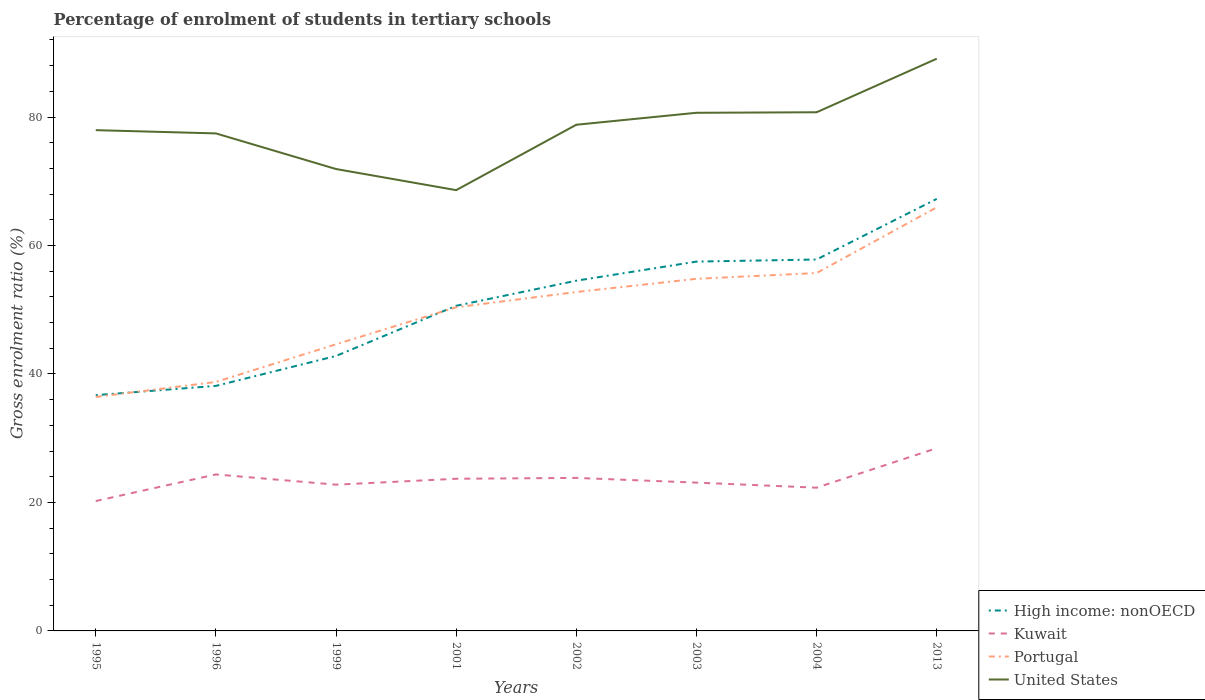How many different coloured lines are there?
Give a very brief answer. 4. Does the line corresponding to High income: nonOECD intersect with the line corresponding to United States?
Make the answer very short. No. Across all years, what is the maximum percentage of students enrolled in tertiary schools in United States?
Provide a succinct answer. 68.62. What is the total percentage of students enrolled in tertiary schools in United States in the graph?
Your answer should be very brief. -8.84. What is the difference between the highest and the second highest percentage of students enrolled in tertiary schools in Portugal?
Keep it short and to the point. 29.52. Is the percentage of students enrolled in tertiary schools in Portugal strictly greater than the percentage of students enrolled in tertiary schools in Kuwait over the years?
Offer a very short reply. No. How many years are there in the graph?
Offer a terse response. 8. Are the values on the major ticks of Y-axis written in scientific E-notation?
Provide a succinct answer. No. Does the graph contain any zero values?
Keep it short and to the point. No. Does the graph contain grids?
Provide a short and direct response. No. How many legend labels are there?
Keep it short and to the point. 4. How are the legend labels stacked?
Make the answer very short. Vertical. What is the title of the graph?
Offer a terse response. Percentage of enrolment of students in tertiary schools. Does "Ethiopia" appear as one of the legend labels in the graph?
Your answer should be very brief. No. What is the label or title of the X-axis?
Provide a succinct answer. Years. What is the Gross enrolment ratio (%) of High income: nonOECD in 1995?
Ensure brevity in your answer.  36.7. What is the Gross enrolment ratio (%) of Kuwait in 1995?
Your response must be concise. 20.22. What is the Gross enrolment ratio (%) in Portugal in 1995?
Provide a succinct answer. 36.43. What is the Gross enrolment ratio (%) in United States in 1995?
Your answer should be very brief. 77.96. What is the Gross enrolment ratio (%) in High income: nonOECD in 1996?
Keep it short and to the point. 38.15. What is the Gross enrolment ratio (%) of Kuwait in 1996?
Give a very brief answer. 24.36. What is the Gross enrolment ratio (%) of Portugal in 1996?
Your answer should be very brief. 38.76. What is the Gross enrolment ratio (%) in United States in 1996?
Ensure brevity in your answer.  77.45. What is the Gross enrolment ratio (%) in High income: nonOECD in 1999?
Your answer should be very brief. 42.8. What is the Gross enrolment ratio (%) in Kuwait in 1999?
Provide a succinct answer. 22.77. What is the Gross enrolment ratio (%) of Portugal in 1999?
Offer a very short reply. 44.62. What is the Gross enrolment ratio (%) in United States in 1999?
Your answer should be compact. 71.91. What is the Gross enrolment ratio (%) in High income: nonOECD in 2001?
Provide a succinct answer. 50.62. What is the Gross enrolment ratio (%) in Kuwait in 2001?
Offer a terse response. 23.69. What is the Gross enrolment ratio (%) in Portugal in 2001?
Your answer should be very brief. 50.38. What is the Gross enrolment ratio (%) in United States in 2001?
Offer a terse response. 68.62. What is the Gross enrolment ratio (%) of High income: nonOECD in 2002?
Offer a very short reply. 54.52. What is the Gross enrolment ratio (%) in Kuwait in 2002?
Your answer should be very brief. 23.82. What is the Gross enrolment ratio (%) of Portugal in 2002?
Provide a short and direct response. 52.76. What is the Gross enrolment ratio (%) of United States in 2002?
Keep it short and to the point. 78.8. What is the Gross enrolment ratio (%) in High income: nonOECD in 2003?
Provide a succinct answer. 57.49. What is the Gross enrolment ratio (%) in Kuwait in 2003?
Offer a terse response. 23.09. What is the Gross enrolment ratio (%) in Portugal in 2003?
Your answer should be very brief. 54.82. What is the Gross enrolment ratio (%) of United States in 2003?
Make the answer very short. 80.66. What is the Gross enrolment ratio (%) in High income: nonOECD in 2004?
Offer a very short reply. 57.82. What is the Gross enrolment ratio (%) of Kuwait in 2004?
Provide a short and direct response. 22.3. What is the Gross enrolment ratio (%) of Portugal in 2004?
Your answer should be compact. 55.71. What is the Gross enrolment ratio (%) in United States in 2004?
Give a very brief answer. 80.74. What is the Gross enrolment ratio (%) in High income: nonOECD in 2013?
Make the answer very short. 67.26. What is the Gross enrolment ratio (%) of Kuwait in 2013?
Make the answer very short. 28.45. What is the Gross enrolment ratio (%) in Portugal in 2013?
Your answer should be very brief. 65.95. What is the Gross enrolment ratio (%) of United States in 2013?
Your answer should be compact. 89.08. Across all years, what is the maximum Gross enrolment ratio (%) in High income: nonOECD?
Your answer should be very brief. 67.26. Across all years, what is the maximum Gross enrolment ratio (%) of Kuwait?
Your answer should be compact. 28.45. Across all years, what is the maximum Gross enrolment ratio (%) in Portugal?
Your response must be concise. 65.95. Across all years, what is the maximum Gross enrolment ratio (%) of United States?
Provide a short and direct response. 89.08. Across all years, what is the minimum Gross enrolment ratio (%) of High income: nonOECD?
Your response must be concise. 36.7. Across all years, what is the minimum Gross enrolment ratio (%) in Kuwait?
Provide a short and direct response. 20.22. Across all years, what is the minimum Gross enrolment ratio (%) in Portugal?
Offer a terse response. 36.43. Across all years, what is the minimum Gross enrolment ratio (%) in United States?
Ensure brevity in your answer.  68.62. What is the total Gross enrolment ratio (%) of High income: nonOECD in the graph?
Provide a succinct answer. 405.37. What is the total Gross enrolment ratio (%) in Kuwait in the graph?
Your answer should be very brief. 188.7. What is the total Gross enrolment ratio (%) of Portugal in the graph?
Offer a very short reply. 399.43. What is the total Gross enrolment ratio (%) of United States in the graph?
Offer a terse response. 625.22. What is the difference between the Gross enrolment ratio (%) of High income: nonOECD in 1995 and that in 1996?
Keep it short and to the point. -1.44. What is the difference between the Gross enrolment ratio (%) in Kuwait in 1995 and that in 1996?
Keep it short and to the point. -4.14. What is the difference between the Gross enrolment ratio (%) in Portugal in 1995 and that in 1996?
Offer a terse response. -2.33. What is the difference between the Gross enrolment ratio (%) of United States in 1995 and that in 1996?
Your answer should be very brief. 0.51. What is the difference between the Gross enrolment ratio (%) of High income: nonOECD in 1995 and that in 1999?
Keep it short and to the point. -6.1. What is the difference between the Gross enrolment ratio (%) in Kuwait in 1995 and that in 1999?
Ensure brevity in your answer.  -2.55. What is the difference between the Gross enrolment ratio (%) in Portugal in 1995 and that in 1999?
Provide a succinct answer. -8.2. What is the difference between the Gross enrolment ratio (%) of United States in 1995 and that in 1999?
Ensure brevity in your answer.  6.05. What is the difference between the Gross enrolment ratio (%) of High income: nonOECD in 1995 and that in 2001?
Give a very brief answer. -13.91. What is the difference between the Gross enrolment ratio (%) of Kuwait in 1995 and that in 2001?
Give a very brief answer. -3.47. What is the difference between the Gross enrolment ratio (%) of Portugal in 1995 and that in 2001?
Your answer should be compact. -13.95. What is the difference between the Gross enrolment ratio (%) in United States in 1995 and that in 2001?
Ensure brevity in your answer.  9.34. What is the difference between the Gross enrolment ratio (%) of High income: nonOECD in 1995 and that in 2002?
Your answer should be compact. -17.82. What is the difference between the Gross enrolment ratio (%) of Kuwait in 1995 and that in 2002?
Provide a short and direct response. -3.6. What is the difference between the Gross enrolment ratio (%) in Portugal in 1995 and that in 2002?
Offer a terse response. -16.33. What is the difference between the Gross enrolment ratio (%) in United States in 1995 and that in 2002?
Provide a succinct answer. -0.84. What is the difference between the Gross enrolment ratio (%) of High income: nonOECD in 1995 and that in 2003?
Ensure brevity in your answer.  -20.79. What is the difference between the Gross enrolment ratio (%) of Kuwait in 1995 and that in 2003?
Ensure brevity in your answer.  -2.87. What is the difference between the Gross enrolment ratio (%) in Portugal in 1995 and that in 2003?
Provide a succinct answer. -18.39. What is the difference between the Gross enrolment ratio (%) in United States in 1995 and that in 2003?
Your answer should be very brief. -2.71. What is the difference between the Gross enrolment ratio (%) in High income: nonOECD in 1995 and that in 2004?
Keep it short and to the point. -21.12. What is the difference between the Gross enrolment ratio (%) of Kuwait in 1995 and that in 2004?
Your answer should be very brief. -2.08. What is the difference between the Gross enrolment ratio (%) of Portugal in 1995 and that in 2004?
Make the answer very short. -19.29. What is the difference between the Gross enrolment ratio (%) of United States in 1995 and that in 2004?
Offer a very short reply. -2.79. What is the difference between the Gross enrolment ratio (%) of High income: nonOECD in 1995 and that in 2013?
Make the answer very short. -30.55. What is the difference between the Gross enrolment ratio (%) in Kuwait in 1995 and that in 2013?
Keep it short and to the point. -8.23. What is the difference between the Gross enrolment ratio (%) of Portugal in 1995 and that in 2013?
Your answer should be compact. -29.52. What is the difference between the Gross enrolment ratio (%) of United States in 1995 and that in 2013?
Your answer should be compact. -11.13. What is the difference between the Gross enrolment ratio (%) in High income: nonOECD in 1996 and that in 1999?
Your answer should be very brief. -4.66. What is the difference between the Gross enrolment ratio (%) of Kuwait in 1996 and that in 1999?
Offer a very short reply. 1.6. What is the difference between the Gross enrolment ratio (%) in Portugal in 1996 and that in 1999?
Your response must be concise. -5.86. What is the difference between the Gross enrolment ratio (%) in United States in 1996 and that in 1999?
Your answer should be very brief. 5.55. What is the difference between the Gross enrolment ratio (%) in High income: nonOECD in 1996 and that in 2001?
Offer a very short reply. -12.47. What is the difference between the Gross enrolment ratio (%) of Kuwait in 1996 and that in 2001?
Provide a short and direct response. 0.68. What is the difference between the Gross enrolment ratio (%) of Portugal in 1996 and that in 2001?
Make the answer very short. -11.62. What is the difference between the Gross enrolment ratio (%) of United States in 1996 and that in 2001?
Give a very brief answer. 8.83. What is the difference between the Gross enrolment ratio (%) in High income: nonOECD in 1996 and that in 2002?
Provide a short and direct response. -16.38. What is the difference between the Gross enrolment ratio (%) of Kuwait in 1996 and that in 2002?
Offer a very short reply. 0.54. What is the difference between the Gross enrolment ratio (%) of Portugal in 1996 and that in 2002?
Provide a succinct answer. -14. What is the difference between the Gross enrolment ratio (%) of United States in 1996 and that in 2002?
Keep it short and to the point. -1.35. What is the difference between the Gross enrolment ratio (%) of High income: nonOECD in 1996 and that in 2003?
Offer a terse response. -19.35. What is the difference between the Gross enrolment ratio (%) in Kuwait in 1996 and that in 2003?
Ensure brevity in your answer.  1.27. What is the difference between the Gross enrolment ratio (%) of Portugal in 1996 and that in 2003?
Your answer should be compact. -16.06. What is the difference between the Gross enrolment ratio (%) in United States in 1996 and that in 2003?
Your response must be concise. -3.21. What is the difference between the Gross enrolment ratio (%) in High income: nonOECD in 1996 and that in 2004?
Make the answer very short. -19.68. What is the difference between the Gross enrolment ratio (%) of Kuwait in 1996 and that in 2004?
Offer a terse response. 2.06. What is the difference between the Gross enrolment ratio (%) of Portugal in 1996 and that in 2004?
Offer a very short reply. -16.95. What is the difference between the Gross enrolment ratio (%) of United States in 1996 and that in 2004?
Ensure brevity in your answer.  -3.29. What is the difference between the Gross enrolment ratio (%) in High income: nonOECD in 1996 and that in 2013?
Provide a short and direct response. -29.11. What is the difference between the Gross enrolment ratio (%) of Kuwait in 1996 and that in 2013?
Your answer should be compact. -4.09. What is the difference between the Gross enrolment ratio (%) of Portugal in 1996 and that in 2013?
Your answer should be compact. -27.18. What is the difference between the Gross enrolment ratio (%) in United States in 1996 and that in 2013?
Provide a short and direct response. -11.63. What is the difference between the Gross enrolment ratio (%) of High income: nonOECD in 1999 and that in 2001?
Your answer should be very brief. -7.81. What is the difference between the Gross enrolment ratio (%) in Kuwait in 1999 and that in 2001?
Your response must be concise. -0.92. What is the difference between the Gross enrolment ratio (%) in Portugal in 1999 and that in 2001?
Offer a terse response. -5.76. What is the difference between the Gross enrolment ratio (%) in United States in 1999 and that in 2001?
Your response must be concise. 3.29. What is the difference between the Gross enrolment ratio (%) in High income: nonOECD in 1999 and that in 2002?
Keep it short and to the point. -11.72. What is the difference between the Gross enrolment ratio (%) in Kuwait in 1999 and that in 2002?
Offer a terse response. -1.05. What is the difference between the Gross enrolment ratio (%) in Portugal in 1999 and that in 2002?
Make the answer very short. -8.14. What is the difference between the Gross enrolment ratio (%) of United States in 1999 and that in 2002?
Provide a short and direct response. -6.89. What is the difference between the Gross enrolment ratio (%) in High income: nonOECD in 1999 and that in 2003?
Ensure brevity in your answer.  -14.69. What is the difference between the Gross enrolment ratio (%) of Kuwait in 1999 and that in 2003?
Give a very brief answer. -0.32. What is the difference between the Gross enrolment ratio (%) in Portugal in 1999 and that in 2003?
Your answer should be compact. -10.19. What is the difference between the Gross enrolment ratio (%) of United States in 1999 and that in 2003?
Offer a terse response. -8.76. What is the difference between the Gross enrolment ratio (%) of High income: nonOECD in 1999 and that in 2004?
Offer a terse response. -15.02. What is the difference between the Gross enrolment ratio (%) of Kuwait in 1999 and that in 2004?
Your answer should be compact. 0.47. What is the difference between the Gross enrolment ratio (%) in Portugal in 1999 and that in 2004?
Offer a terse response. -11.09. What is the difference between the Gross enrolment ratio (%) of United States in 1999 and that in 2004?
Ensure brevity in your answer.  -8.84. What is the difference between the Gross enrolment ratio (%) in High income: nonOECD in 1999 and that in 2013?
Your answer should be very brief. -24.45. What is the difference between the Gross enrolment ratio (%) in Kuwait in 1999 and that in 2013?
Give a very brief answer. -5.68. What is the difference between the Gross enrolment ratio (%) of Portugal in 1999 and that in 2013?
Your response must be concise. -21.32. What is the difference between the Gross enrolment ratio (%) of United States in 1999 and that in 2013?
Give a very brief answer. -17.18. What is the difference between the Gross enrolment ratio (%) in High income: nonOECD in 2001 and that in 2002?
Your response must be concise. -3.91. What is the difference between the Gross enrolment ratio (%) in Kuwait in 2001 and that in 2002?
Provide a short and direct response. -0.13. What is the difference between the Gross enrolment ratio (%) in Portugal in 2001 and that in 2002?
Your response must be concise. -2.38. What is the difference between the Gross enrolment ratio (%) of United States in 2001 and that in 2002?
Provide a short and direct response. -10.18. What is the difference between the Gross enrolment ratio (%) of High income: nonOECD in 2001 and that in 2003?
Your response must be concise. -6.88. What is the difference between the Gross enrolment ratio (%) of Kuwait in 2001 and that in 2003?
Provide a short and direct response. 0.6. What is the difference between the Gross enrolment ratio (%) of Portugal in 2001 and that in 2003?
Your answer should be very brief. -4.44. What is the difference between the Gross enrolment ratio (%) in United States in 2001 and that in 2003?
Your answer should be compact. -12.04. What is the difference between the Gross enrolment ratio (%) of High income: nonOECD in 2001 and that in 2004?
Offer a very short reply. -7.21. What is the difference between the Gross enrolment ratio (%) in Kuwait in 2001 and that in 2004?
Make the answer very short. 1.39. What is the difference between the Gross enrolment ratio (%) of Portugal in 2001 and that in 2004?
Your answer should be very brief. -5.33. What is the difference between the Gross enrolment ratio (%) in United States in 2001 and that in 2004?
Provide a short and direct response. -12.12. What is the difference between the Gross enrolment ratio (%) in High income: nonOECD in 2001 and that in 2013?
Provide a short and direct response. -16.64. What is the difference between the Gross enrolment ratio (%) of Kuwait in 2001 and that in 2013?
Your response must be concise. -4.76. What is the difference between the Gross enrolment ratio (%) in Portugal in 2001 and that in 2013?
Offer a very short reply. -15.57. What is the difference between the Gross enrolment ratio (%) in United States in 2001 and that in 2013?
Give a very brief answer. -20.46. What is the difference between the Gross enrolment ratio (%) of High income: nonOECD in 2002 and that in 2003?
Offer a terse response. -2.97. What is the difference between the Gross enrolment ratio (%) of Kuwait in 2002 and that in 2003?
Ensure brevity in your answer.  0.73. What is the difference between the Gross enrolment ratio (%) in Portugal in 2002 and that in 2003?
Offer a very short reply. -2.06. What is the difference between the Gross enrolment ratio (%) of United States in 2002 and that in 2003?
Provide a succinct answer. -1.86. What is the difference between the Gross enrolment ratio (%) in High income: nonOECD in 2002 and that in 2004?
Keep it short and to the point. -3.3. What is the difference between the Gross enrolment ratio (%) of Kuwait in 2002 and that in 2004?
Your response must be concise. 1.52. What is the difference between the Gross enrolment ratio (%) of Portugal in 2002 and that in 2004?
Give a very brief answer. -2.95. What is the difference between the Gross enrolment ratio (%) of United States in 2002 and that in 2004?
Ensure brevity in your answer.  -1.94. What is the difference between the Gross enrolment ratio (%) in High income: nonOECD in 2002 and that in 2013?
Your response must be concise. -12.74. What is the difference between the Gross enrolment ratio (%) of Kuwait in 2002 and that in 2013?
Make the answer very short. -4.63. What is the difference between the Gross enrolment ratio (%) of Portugal in 2002 and that in 2013?
Your answer should be very brief. -13.18. What is the difference between the Gross enrolment ratio (%) in United States in 2002 and that in 2013?
Ensure brevity in your answer.  -10.28. What is the difference between the Gross enrolment ratio (%) in High income: nonOECD in 2003 and that in 2004?
Provide a succinct answer. -0.33. What is the difference between the Gross enrolment ratio (%) in Kuwait in 2003 and that in 2004?
Offer a very short reply. 0.79. What is the difference between the Gross enrolment ratio (%) of Portugal in 2003 and that in 2004?
Offer a terse response. -0.89. What is the difference between the Gross enrolment ratio (%) of United States in 2003 and that in 2004?
Provide a short and direct response. -0.08. What is the difference between the Gross enrolment ratio (%) in High income: nonOECD in 2003 and that in 2013?
Provide a short and direct response. -9.76. What is the difference between the Gross enrolment ratio (%) in Kuwait in 2003 and that in 2013?
Give a very brief answer. -5.36. What is the difference between the Gross enrolment ratio (%) of Portugal in 2003 and that in 2013?
Make the answer very short. -11.13. What is the difference between the Gross enrolment ratio (%) in United States in 2003 and that in 2013?
Give a very brief answer. -8.42. What is the difference between the Gross enrolment ratio (%) of High income: nonOECD in 2004 and that in 2013?
Give a very brief answer. -9.44. What is the difference between the Gross enrolment ratio (%) in Kuwait in 2004 and that in 2013?
Ensure brevity in your answer.  -6.15. What is the difference between the Gross enrolment ratio (%) of Portugal in 2004 and that in 2013?
Your answer should be very brief. -10.23. What is the difference between the Gross enrolment ratio (%) in United States in 2004 and that in 2013?
Provide a succinct answer. -8.34. What is the difference between the Gross enrolment ratio (%) of High income: nonOECD in 1995 and the Gross enrolment ratio (%) of Kuwait in 1996?
Ensure brevity in your answer.  12.34. What is the difference between the Gross enrolment ratio (%) in High income: nonOECD in 1995 and the Gross enrolment ratio (%) in Portugal in 1996?
Provide a succinct answer. -2.06. What is the difference between the Gross enrolment ratio (%) in High income: nonOECD in 1995 and the Gross enrolment ratio (%) in United States in 1996?
Provide a succinct answer. -40.75. What is the difference between the Gross enrolment ratio (%) of Kuwait in 1995 and the Gross enrolment ratio (%) of Portugal in 1996?
Provide a short and direct response. -18.54. What is the difference between the Gross enrolment ratio (%) in Kuwait in 1995 and the Gross enrolment ratio (%) in United States in 1996?
Give a very brief answer. -57.23. What is the difference between the Gross enrolment ratio (%) of Portugal in 1995 and the Gross enrolment ratio (%) of United States in 1996?
Give a very brief answer. -41.02. What is the difference between the Gross enrolment ratio (%) in High income: nonOECD in 1995 and the Gross enrolment ratio (%) in Kuwait in 1999?
Offer a terse response. 13.94. What is the difference between the Gross enrolment ratio (%) of High income: nonOECD in 1995 and the Gross enrolment ratio (%) of Portugal in 1999?
Make the answer very short. -7.92. What is the difference between the Gross enrolment ratio (%) of High income: nonOECD in 1995 and the Gross enrolment ratio (%) of United States in 1999?
Make the answer very short. -35.2. What is the difference between the Gross enrolment ratio (%) of Kuwait in 1995 and the Gross enrolment ratio (%) of Portugal in 1999?
Make the answer very short. -24.4. What is the difference between the Gross enrolment ratio (%) in Kuwait in 1995 and the Gross enrolment ratio (%) in United States in 1999?
Offer a very short reply. -51.68. What is the difference between the Gross enrolment ratio (%) of Portugal in 1995 and the Gross enrolment ratio (%) of United States in 1999?
Ensure brevity in your answer.  -35.48. What is the difference between the Gross enrolment ratio (%) in High income: nonOECD in 1995 and the Gross enrolment ratio (%) in Kuwait in 2001?
Provide a short and direct response. 13.02. What is the difference between the Gross enrolment ratio (%) of High income: nonOECD in 1995 and the Gross enrolment ratio (%) of Portugal in 2001?
Provide a short and direct response. -13.68. What is the difference between the Gross enrolment ratio (%) in High income: nonOECD in 1995 and the Gross enrolment ratio (%) in United States in 2001?
Your answer should be very brief. -31.91. What is the difference between the Gross enrolment ratio (%) in Kuwait in 1995 and the Gross enrolment ratio (%) in Portugal in 2001?
Offer a terse response. -30.16. What is the difference between the Gross enrolment ratio (%) of Kuwait in 1995 and the Gross enrolment ratio (%) of United States in 2001?
Ensure brevity in your answer.  -48.4. What is the difference between the Gross enrolment ratio (%) of Portugal in 1995 and the Gross enrolment ratio (%) of United States in 2001?
Ensure brevity in your answer.  -32.19. What is the difference between the Gross enrolment ratio (%) in High income: nonOECD in 1995 and the Gross enrolment ratio (%) in Kuwait in 2002?
Ensure brevity in your answer.  12.88. What is the difference between the Gross enrolment ratio (%) in High income: nonOECD in 1995 and the Gross enrolment ratio (%) in Portugal in 2002?
Ensure brevity in your answer.  -16.06. What is the difference between the Gross enrolment ratio (%) in High income: nonOECD in 1995 and the Gross enrolment ratio (%) in United States in 2002?
Your answer should be compact. -42.1. What is the difference between the Gross enrolment ratio (%) of Kuwait in 1995 and the Gross enrolment ratio (%) of Portugal in 2002?
Keep it short and to the point. -32.54. What is the difference between the Gross enrolment ratio (%) of Kuwait in 1995 and the Gross enrolment ratio (%) of United States in 2002?
Make the answer very short. -58.58. What is the difference between the Gross enrolment ratio (%) in Portugal in 1995 and the Gross enrolment ratio (%) in United States in 2002?
Keep it short and to the point. -42.37. What is the difference between the Gross enrolment ratio (%) in High income: nonOECD in 1995 and the Gross enrolment ratio (%) in Kuwait in 2003?
Your answer should be compact. 13.62. What is the difference between the Gross enrolment ratio (%) in High income: nonOECD in 1995 and the Gross enrolment ratio (%) in Portugal in 2003?
Keep it short and to the point. -18.11. What is the difference between the Gross enrolment ratio (%) of High income: nonOECD in 1995 and the Gross enrolment ratio (%) of United States in 2003?
Provide a succinct answer. -43.96. What is the difference between the Gross enrolment ratio (%) in Kuwait in 1995 and the Gross enrolment ratio (%) in Portugal in 2003?
Give a very brief answer. -34.6. What is the difference between the Gross enrolment ratio (%) in Kuwait in 1995 and the Gross enrolment ratio (%) in United States in 2003?
Make the answer very short. -60.44. What is the difference between the Gross enrolment ratio (%) of Portugal in 1995 and the Gross enrolment ratio (%) of United States in 2003?
Ensure brevity in your answer.  -44.24. What is the difference between the Gross enrolment ratio (%) of High income: nonOECD in 1995 and the Gross enrolment ratio (%) of Kuwait in 2004?
Provide a succinct answer. 14.4. What is the difference between the Gross enrolment ratio (%) in High income: nonOECD in 1995 and the Gross enrolment ratio (%) in Portugal in 2004?
Your response must be concise. -19.01. What is the difference between the Gross enrolment ratio (%) in High income: nonOECD in 1995 and the Gross enrolment ratio (%) in United States in 2004?
Provide a succinct answer. -44.04. What is the difference between the Gross enrolment ratio (%) of Kuwait in 1995 and the Gross enrolment ratio (%) of Portugal in 2004?
Provide a short and direct response. -35.49. What is the difference between the Gross enrolment ratio (%) of Kuwait in 1995 and the Gross enrolment ratio (%) of United States in 2004?
Make the answer very short. -60.52. What is the difference between the Gross enrolment ratio (%) in Portugal in 1995 and the Gross enrolment ratio (%) in United States in 2004?
Make the answer very short. -44.32. What is the difference between the Gross enrolment ratio (%) of High income: nonOECD in 1995 and the Gross enrolment ratio (%) of Kuwait in 2013?
Your response must be concise. 8.25. What is the difference between the Gross enrolment ratio (%) of High income: nonOECD in 1995 and the Gross enrolment ratio (%) of Portugal in 2013?
Offer a terse response. -29.24. What is the difference between the Gross enrolment ratio (%) of High income: nonOECD in 1995 and the Gross enrolment ratio (%) of United States in 2013?
Provide a succinct answer. -52.38. What is the difference between the Gross enrolment ratio (%) of Kuwait in 1995 and the Gross enrolment ratio (%) of Portugal in 2013?
Your answer should be very brief. -45.72. What is the difference between the Gross enrolment ratio (%) in Kuwait in 1995 and the Gross enrolment ratio (%) in United States in 2013?
Provide a short and direct response. -68.86. What is the difference between the Gross enrolment ratio (%) of Portugal in 1995 and the Gross enrolment ratio (%) of United States in 2013?
Your response must be concise. -52.66. What is the difference between the Gross enrolment ratio (%) of High income: nonOECD in 1996 and the Gross enrolment ratio (%) of Kuwait in 1999?
Ensure brevity in your answer.  15.38. What is the difference between the Gross enrolment ratio (%) in High income: nonOECD in 1996 and the Gross enrolment ratio (%) in Portugal in 1999?
Your answer should be compact. -6.48. What is the difference between the Gross enrolment ratio (%) of High income: nonOECD in 1996 and the Gross enrolment ratio (%) of United States in 1999?
Ensure brevity in your answer.  -33.76. What is the difference between the Gross enrolment ratio (%) of Kuwait in 1996 and the Gross enrolment ratio (%) of Portugal in 1999?
Ensure brevity in your answer.  -20.26. What is the difference between the Gross enrolment ratio (%) of Kuwait in 1996 and the Gross enrolment ratio (%) of United States in 1999?
Make the answer very short. -47.54. What is the difference between the Gross enrolment ratio (%) in Portugal in 1996 and the Gross enrolment ratio (%) in United States in 1999?
Provide a short and direct response. -33.14. What is the difference between the Gross enrolment ratio (%) of High income: nonOECD in 1996 and the Gross enrolment ratio (%) of Kuwait in 2001?
Ensure brevity in your answer.  14.46. What is the difference between the Gross enrolment ratio (%) of High income: nonOECD in 1996 and the Gross enrolment ratio (%) of Portugal in 2001?
Offer a terse response. -12.23. What is the difference between the Gross enrolment ratio (%) of High income: nonOECD in 1996 and the Gross enrolment ratio (%) of United States in 2001?
Provide a succinct answer. -30.47. What is the difference between the Gross enrolment ratio (%) in Kuwait in 1996 and the Gross enrolment ratio (%) in Portugal in 2001?
Provide a succinct answer. -26.02. What is the difference between the Gross enrolment ratio (%) in Kuwait in 1996 and the Gross enrolment ratio (%) in United States in 2001?
Give a very brief answer. -44.25. What is the difference between the Gross enrolment ratio (%) in Portugal in 1996 and the Gross enrolment ratio (%) in United States in 2001?
Give a very brief answer. -29.86. What is the difference between the Gross enrolment ratio (%) of High income: nonOECD in 1996 and the Gross enrolment ratio (%) of Kuwait in 2002?
Keep it short and to the point. 14.33. What is the difference between the Gross enrolment ratio (%) of High income: nonOECD in 1996 and the Gross enrolment ratio (%) of Portugal in 2002?
Your answer should be very brief. -14.61. What is the difference between the Gross enrolment ratio (%) in High income: nonOECD in 1996 and the Gross enrolment ratio (%) in United States in 2002?
Give a very brief answer. -40.65. What is the difference between the Gross enrolment ratio (%) in Kuwait in 1996 and the Gross enrolment ratio (%) in Portugal in 2002?
Make the answer very short. -28.4. What is the difference between the Gross enrolment ratio (%) of Kuwait in 1996 and the Gross enrolment ratio (%) of United States in 2002?
Ensure brevity in your answer.  -54.44. What is the difference between the Gross enrolment ratio (%) in Portugal in 1996 and the Gross enrolment ratio (%) in United States in 2002?
Provide a short and direct response. -40.04. What is the difference between the Gross enrolment ratio (%) in High income: nonOECD in 1996 and the Gross enrolment ratio (%) in Kuwait in 2003?
Offer a very short reply. 15.06. What is the difference between the Gross enrolment ratio (%) in High income: nonOECD in 1996 and the Gross enrolment ratio (%) in Portugal in 2003?
Provide a short and direct response. -16.67. What is the difference between the Gross enrolment ratio (%) in High income: nonOECD in 1996 and the Gross enrolment ratio (%) in United States in 2003?
Offer a very short reply. -42.52. What is the difference between the Gross enrolment ratio (%) of Kuwait in 1996 and the Gross enrolment ratio (%) of Portugal in 2003?
Provide a short and direct response. -30.45. What is the difference between the Gross enrolment ratio (%) in Kuwait in 1996 and the Gross enrolment ratio (%) in United States in 2003?
Provide a short and direct response. -56.3. What is the difference between the Gross enrolment ratio (%) of Portugal in 1996 and the Gross enrolment ratio (%) of United States in 2003?
Your answer should be compact. -41.9. What is the difference between the Gross enrolment ratio (%) in High income: nonOECD in 1996 and the Gross enrolment ratio (%) in Kuwait in 2004?
Your answer should be compact. 15.85. What is the difference between the Gross enrolment ratio (%) of High income: nonOECD in 1996 and the Gross enrolment ratio (%) of Portugal in 2004?
Provide a short and direct response. -17.56. What is the difference between the Gross enrolment ratio (%) of High income: nonOECD in 1996 and the Gross enrolment ratio (%) of United States in 2004?
Provide a short and direct response. -42.6. What is the difference between the Gross enrolment ratio (%) of Kuwait in 1996 and the Gross enrolment ratio (%) of Portugal in 2004?
Provide a succinct answer. -31.35. What is the difference between the Gross enrolment ratio (%) of Kuwait in 1996 and the Gross enrolment ratio (%) of United States in 2004?
Your answer should be compact. -56.38. What is the difference between the Gross enrolment ratio (%) in Portugal in 1996 and the Gross enrolment ratio (%) in United States in 2004?
Provide a succinct answer. -41.98. What is the difference between the Gross enrolment ratio (%) of High income: nonOECD in 1996 and the Gross enrolment ratio (%) of Kuwait in 2013?
Ensure brevity in your answer.  9.7. What is the difference between the Gross enrolment ratio (%) in High income: nonOECD in 1996 and the Gross enrolment ratio (%) in Portugal in 2013?
Ensure brevity in your answer.  -27.8. What is the difference between the Gross enrolment ratio (%) in High income: nonOECD in 1996 and the Gross enrolment ratio (%) in United States in 2013?
Provide a short and direct response. -50.94. What is the difference between the Gross enrolment ratio (%) in Kuwait in 1996 and the Gross enrolment ratio (%) in Portugal in 2013?
Offer a very short reply. -41.58. What is the difference between the Gross enrolment ratio (%) of Kuwait in 1996 and the Gross enrolment ratio (%) of United States in 2013?
Make the answer very short. -64.72. What is the difference between the Gross enrolment ratio (%) of Portugal in 1996 and the Gross enrolment ratio (%) of United States in 2013?
Ensure brevity in your answer.  -50.32. What is the difference between the Gross enrolment ratio (%) of High income: nonOECD in 1999 and the Gross enrolment ratio (%) of Kuwait in 2001?
Provide a short and direct response. 19.12. What is the difference between the Gross enrolment ratio (%) in High income: nonOECD in 1999 and the Gross enrolment ratio (%) in Portugal in 2001?
Make the answer very short. -7.58. What is the difference between the Gross enrolment ratio (%) in High income: nonOECD in 1999 and the Gross enrolment ratio (%) in United States in 2001?
Your answer should be compact. -25.81. What is the difference between the Gross enrolment ratio (%) of Kuwait in 1999 and the Gross enrolment ratio (%) of Portugal in 2001?
Ensure brevity in your answer.  -27.61. What is the difference between the Gross enrolment ratio (%) in Kuwait in 1999 and the Gross enrolment ratio (%) in United States in 2001?
Offer a terse response. -45.85. What is the difference between the Gross enrolment ratio (%) in Portugal in 1999 and the Gross enrolment ratio (%) in United States in 2001?
Give a very brief answer. -23.99. What is the difference between the Gross enrolment ratio (%) in High income: nonOECD in 1999 and the Gross enrolment ratio (%) in Kuwait in 2002?
Your response must be concise. 18.98. What is the difference between the Gross enrolment ratio (%) of High income: nonOECD in 1999 and the Gross enrolment ratio (%) of Portugal in 2002?
Provide a short and direct response. -9.96. What is the difference between the Gross enrolment ratio (%) in High income: nonOECD in 1999 and the Gross enrolment ratio (%) in United States in 2002?
Keep it short and to the point. -36. What is the difference between the Gross enrolment ratio (%) of Kuwait in 1999 and the Gross enrolment ratio (%) of Portugal in 2002?
Provide a succinct answer. -29.99. What is the difference between the Gross enrolment ratio (%) in Kuwait in 1999 and the Gross enrolment ratio (%) in United States in 2002?
Offer a very short reply. -56.03. What is the difference between the Gross enrolment ratio (%) of Portugal in 1999 and the Gross enrolment ratio (%) of United States in 2002?
Provide a succinct answer. -34.18. What is the difference between the Gross enrolment ratio (%) in High income: nonOECD in 1999 and the Gross enrolment ratio (%) in Kuwait in 2003?
Provide a short and direct response. 19.72. What is the difference between the Gross enrolment ratio (%) of High income: nonOECD in 1999 and the Gross enrolment ratio (%) of Portugal in 2003?
Provide a succinct answer. -12.01. What is the difference between the Gross enrolment ratio (%) in High income: nonOECD in 1999 and the Gross enrolment ratio (%) in United States in 2003?
Offer a terse response. -37.86. What is the difference between the Gross enrolment ratio (%) of Kuwait in 1999 and the Gross enrolment ratio (%) of Portugal in 2003?
Keep it short and to the point. -32.05. What is the difference between the Gross enrolment ratio (%) in Kuwait in 1999 and the Gross enrolment ratio (%) in United States in 2003?
Ensure brevity in your answer.  -57.9. What is the difference between the Gross enrolment ratio (%) of Portugal in 1999 and the Gross enrolment ratio (%) of United States in 2003?
Give a very brief answer. -36.04. What is the difference between the Gross enrolment ratio (%) of High income: nonOECD in 1999 and the Gross enrolment ratio (%) of Kuwait in 2004?
Your answer should be very brief. 20.5. What is the difference between the Gross enrolment ratio (%) in High income: nonOECD in 1999 and the Gross enrolment ratio (%) in Portugal in 2004?
Offer a very short reply. -12.91. What is the difference between the Gross enrolment ratio (%) in High income: nonOECD in 1999 and the Gross enrolment ratio (%) in United States in 2004?
Your response must be concise. -37.94. What is the difference between the Gross enrolment ratio (%) of Kuwait in 1999 and the Gross enrolment ratio (%) of Portugal in 2004?
Provide a succinct answer. -32.94. What is the difference between the Gross enrolment ratio (%) in Kuwait in 1999 and the Gross enrolment ratio (%) in United States in 2004?
Keep it short and to the point. -57.97. What is the difference between the Gross enrolment ratio (%) in Portugal in 1999 and the Gross enrolment ratio (%) in United States in 2004?
Keep it short and to the point. -36.12. What is the difference between the Gross enrolment ratio (%) in High income: nonOECD in 1999 and the Gross enrolment ratio (%) in Kuwait in 2013?
Ensure brevity in your answer.  14.35. What is the difference between the Gross enrolment ratio (%) of High income: nonOECD in 1999 and the Gross enrolment ratio (%) of Portugal in 2013?
Provide a succinct answer. -23.14. What is the difference between the Gross enrolment ratio (%) of High income: nonOECD in 1999 and the Gross enrolment ratio (%) of United States in 2013?
Provide a succinct answer. -46.28. What is the difference between the Gross enrolment ratio (%) of Kuwait in 1999 and the Gross enrolment ratio (%) of Portugal in 2013?
Your answer should be compact. -43.18. What is the difference between the Gross enrolment ratio (%) in Kuwait in 1999 and the Gross enrolment ratio (%) in United States in 2013?
Provide a short and direct response. -66.31. What is the difference between the Gross enrolment ratio (%) of Portugal in 1999 and the Gross enrolment ratio (%) of United States in 2013?
Give a very brief answer. -44.46. What is the difference between the Gross enrolment ratio (%) in High income: nonOECD in 2001 and the Gross enrolment ratio (%) in Kuwait in 2002?
Provide a short and direct response. 26.79. What is the difference between the Gross enrolment ratio (%) of High income: nonOECD in 2001 and the Gross enrolment ratio (%) of Portugal in 2002?
Keep it short and to the point. -2.15. What is the difference between the Gross enrolment ratio (%) in High income: nonOECD in 2001 and the Gross enrolment ratio (%) in United States in 2002?
Your answer should be compact. -28.18. What is the difference between the Gross enrolment ratio (%) in Kuwait in 2001 and the Gross enrolment ratio (%) in Portugal in 2002?
Your answer should be very brief. -29.07. What is the difference between the Gross enrolment ratio (%) in Kuwait in 2001 and the Gross enrolment ratio (%) in United States in 2002?
Offer a very short reply. -55.11. What is the difference between the Gross enrolment ratio (%) in Portugal in 2001 and the Gross enrolment ratio (%) in United States in 2002?
Offer a very short reply. -28.42. What is the difference between the Gross enrolment ratio (%) of High income: nonOECD in 2001 and the Gross enrolment ratio (%) of Kuwait in 2003?
Offer a terse response. 27.53. What is the difference between the Gross enrolment ratio (%) of High income: nonOECD in 2001 and the Gross enrolment ratio (%) of Portugal in 2003?
Give a very brief answer. -4.2. What is the difference between the Gross enrolment ratio (%) of High income: nonOECD in 2001 and the Gross enrolment ratio (%) of United States in 2003?
Your answer should be very brief. -30.05. What is the difference between the Gross enrolment ratio (%) in Kuwait in 2001 and the Gross enrolment ratio (%) in Portugal in 2003?
Offer a terse response. -31.13. What is the difference between the Gross enrolment ratio (%) in Kuwait in 2001 and the Gross enrolment ratio (%) in United States in 2003?
Ensure brevity in your answer.  -56.98. What is the difference between the Gross enrolment ratio (%) of Portugal in 2001 and the Gross enrolment ratio (%) of United States in 2003?
Your response must be concise. -30.28. What is the difference between the Gross enrolment ratio (%) in High income: nonOECD in 2001 and the Gross enrolment ratio (%) in Kuwait in 2004?
Provide a short and direct response. 28.32. What is the difference between the Gross enrolment ratio (%) in High income: nonOECD in 2001 and the Gross enrolment ratio (%) in Portugal in 2004?
Make the answer very short. -5.1. What is the difference between the Gross enrolment ratio (%) of High income: nonOECD in 2001 and the Gross enrolment ratio (%) of United States in 2004?
Keep it short and to the point. -30.13. What is the difference between the Gross enrolment ratio (%) in Kuwait in 2001 and the Gross enrolment ratio (%) in Portugal in 2004?
Provide a short and direct response. -32.02. What is the difference between the Gross enrolment ratio (%) of Kuwait in 2001 and the Gross enrolment ratio (%) of United States in 2004?
Offer a very short reply. -57.05. What is the difference between the Gross enrolment ratio (%) of Portugal in 2001 and the Gross enrolment ratio (%) of United States in 2004?
Offer a very short reply. -30.36. What is the difference between the Gross enrolment ratio (%) in High income: nonOECD in 2001 and the Gross enrolment ratio (%) in Kuwait in 2013?
Make the answer very short. 22.16. What is the difference between the Gross enrolment ratio (%) in High income: nonOECD in 2001 and the Gross enrolment ratio (%) in Portugal in 2013?
Provide a short and direct response. -15.33. What is the difference between the Gross enrolment ratio (%) in High income: nonOECD in 2001 and the Gross enrolment ratio (%) in United States in 2013?
Provide a succinct answer. -38.47. What is the difference between the Gross enrolment ratio (%) in Kuwait in 2001 and the Gross enrolment ratio (%) in Portugal in 2013?
Provide a succinct answer. -42.26. What is the difference between the Gross enrolment ratio (%) of Kuwait in 2001 and the Gross enrolment ratio (%) of United States in 2013?
Make the answer very short. -65.39. What is the difference between the Gross enrolment ratio (%) of Portugal in 2001 and the Gross enrolment ratio (%) of United States in 2013?
Give a very brief answer. -38.7. What is the difference between the Gross enrolment ratio (%) of High income: nonOECD in 2002 and the Gross enrolment ratio (%) of Kuwait in 2003?
Give a very brief answer. 31.43. What is the difference between the Gross enrolment ratio (%) in High income: nonOECD in 2002 and the Gross enrolment ratio (%) in Portugal in 2003?
Provide a succinct answer. -0.3. What is the difference between the Gross enrolment ratio (%) in High income: nonOECD in 2002 and the Gross enrolment ratio (%) in United States in 2003?
Ensure brevity in your answer.  -26.14. What is the difference between the Gross enrolment ratio (%) in Kuwait in 2002 and the Gross enrolment ratio (%) in Portugal in 2003?
Keep it short and to the point. -31. What is the difference between the Gross enrolment ratio (%) of Kuwait in 2002 and the Gross enrolment ratio (%) of United States in 2003?
Give a very brief answer. -56.84. What is the difference between the Gross enrolment ratio (%) in Portugal in 2002 and the Gross enrolment ratio (%) in United States in 2003?
Offer a terse response. -27.9. What is the difference between the Gross enrolment ratio (%) in High income: nonOECD in 2002 and the Gross enrolment ratio (%) in Kuwait in 2004?
Ensure brevity in your answer.  32.22. What is the difference between the Gross enrolment ratio (%) in High income: nonOECD in 2002 and the Gross enrolment ratio (%) in Portugal in 2004?
Your answer should be compact. -1.19. What is the difference between the Gross enrolment ratio (%) of High income: nonOECD in 2002 and the Gross enrolment ratio (%) of United States in 2004?
Your answer should be compact. -26.22. What is the difference between the Gross enrolment ratio (%) of Kuwait in 2002 and the Gross enrolment ratio (%) of Portugal in 2004?
Ensure brevity in your answer.  -31.89. What is the difference between the Gross enrolment ratio (%) of Kuwait in 2002 and the Gross enrolment ratio (%) of United States in 2004?
Make the answer very short. -56.92. What is the difference between the Gross enrolment ratio (%) in Portugal in 2002 and the Gross enrolment ratio (%) in United States in 2004?
Offer a very short reply. -27.98. What is the difference between the Gross enrolment ratio (%) in High income: nonOECD in 2002 and the Gross enrolment ratio (%) in Kuwait in 2013?
Offer a terse response. 26.07. What is the difference between the Gross enrolment ratio (%) in High income: nonOECD in 2002 and the Gross enrolment ratio (%) in Portugal in 2013?
Offer a very short reply. -11.42. What is the difference between the Gross enrolment ratio (%) of High income: nonOECD in 2002 and the Gross enrolment ratio (%) of United States in 2013?
Offer a very short reply. -34.56. What is the difference between the Gross enrolment ratio (%) in Kuwait in 2002 and the Gross enrolment ratio (%) in Portugal in 2013?
Give a very brief answer. -42.12. What is the difference between the Gross enrolment ratio (%) in Kuwait in 2002 and the Gross enrolment ratio (%) in United States in 2013?
Ensure brevity in your answer.  -65.26. What is the difference between the Gross enrolment ratio (%) in Portugal in 2002 and the Gross enrolment ratio (%) in United States in 2013?
Offer a terse response. -36.32. What is the difference between the Gross enrolment ratio (%) of High income: nonOECD in 2003 and the Gross enrolment ratio (%) of Kuwait in 2004?
Your answer should be compact. 35.19. What is the difference between the Gross enrolment ratio (%) of High income: nonOECD in 2003 and the Gross enrolment ratio (%) of Portugal in 2004?
Your answer should be compact. 1.78. What is the difference between the Gross enrolment ratio (%) of High income: nonOECD in 2003 and the Gross enrolment ratio (%) of United States in 2004?
Provide a succinct answer. -23.25. What is the difference between the Gross enrolment ratio (%) in Kuwait in 2003 and the Gross enrolment ratio (%) in Portugal in 2004?
Make the answer very short. -32.62. What is the difference between the Gross enrolment ratio (%) in Kuwait in 2003 and the Gross enrolment ratio (%) in United States in 2004?
Your answer should be very brief. -57.65. What is the difference between the Gross enrolment ratio (%) of Portugal in 2003 and the Gross enrolment ratio (%) of United States in 2004?
Your answer should be compact. -25.92. What is the difference between the Gross enrolment ratio (%) of High income: nonOECD in 2003 and the Gross enrolment ratio (%) of Kuwait in 2013?
Keep it short and to the point. 29.04. What is the difference between the Gross enrolment ratio (%) in High income: nonOECD in 2003 and the Gross enrolment ratio (%) in Portugal in 2013?
Ensure brevity in your answer.  -8.45. What is the difference between the Gross enrolment ratio (%) of High income: nonOECD in 2003 and the Gross enrolment ratio (%) of United States in 2013?
Give a very brief answer. -31.59. What is the difference between the Gross enrolment ratio (%) of Kuwait in 2003 and the Gross enrolment ratio (%) of Portugal in 2013?
Give a very brief answer. -42.86. What is the difference between the Gross enrolment ratio (%) of Kuwait in 2003 and the Gross enrolment ratio (%) of United States in 2013?
Provide a short and direct response. -65.99. What is the difference between the Gross enrolment ratio (%) of Portugal in 2003 and the Gross enrolment ratio (%) of United States in 2013?
Provide a short and direct response. -34.27. What is the difference between the Gross enrolment ratio (%) in High income: nonOECD in 2004 and the Gross enrolment ratio (%) in Kuwait in 2013?
Offer a terse response. 29.37. What is the difference between the Gross enrolment ratio (%) in High income: nonOECD in 2004 and the Gross enrolment ratio (%) in Portugal in 2013?
Your answer should be compact. -8.12. What is the difference between the Gross enrolment ratio (%) of High income: nonOECD in 2004 and the Gross enrolment ratio (%) of United States in 2013?
Offer a very short reply. -31.26. What is the difference between the Gross enrolment ratio (%) of Kuwait in 2004 and the Gross enrolment ratio (%) of Portugal in 2013?
Your response must be concise. -43.65. What is the difference between the Gross enrolment ratio (%) in Kuwait in 2004 and the Gross enrolment ratio (%) in United States in 2013?
Offer a terse response. -66.78. What is the difference between the Gross enrolment ratio (%) of Portugal in 2004 and the Gross enrolment ratio (%) of United States in 2013?
Keep it short and to the point. -33.37. What is the average Gross enrolment ratio (%) in High income: nonOECD per year?
Your response must be concise. 50.67. What is the average Gross enrolment ratio (%) of Kuwait per year?
Your answer should be very brief. 23.59. What is the average Gross enrolment ratio (%) of Portugal per year?
Keep it short and to the point. 49.93. What is the average Gross enrolment ratio (%) in United States per year?
Your answer should be very brief. 78.15. In the year 1995, what is the difference between the Gross enrolment ratio (%) of High income: nonOECD and Gross enrolment ratio (%) of Kuwait?
Your response must be concise. 16.48. In the year 1995, what is the difference between the Gross enrolment ratio (%) of High income: nonOECD and Gross enrolment ratio (%) of Portugal?
Your answer should be compact. 0.28. In the year 1995, what is the difference between the Gross enrolment ratio (%) of High income: nonOECD and Gross enrolment ratio (%) of United States?
Provide a succinct answer. -41.25. In the year 1995, what is the difference between the Gross enrolment ratio (%) in Kuwait and Gross enrolment ratio (%) in Portugal?
Keep it short and to the point. -16.2. In the year 1995, what is the difference between the Gross enrolment ratio (%) of Kuwait and Gross enrolment ratio (%) of United States?
Keep it short and to the point. -57.73. In the year 1995, what is the difference between the Gross enrolment ratio (%) of Portugal and Gross enrolment ratio (%) of United States?
Your answer should be very brief. -41.53. In the year 1996, what is the difference between the Gross enrolment ratio (%) in High income: nonOECD and Gross enrolment ratio (%) in Kuwait?
Offer a terse response. 13.78. In the year 1996, what is the difference between the Gross enrolment ratio (%) in High income: nonOECD and Gross enrolment ratio (%) in Portugal?
Provide a succinct answer. -0.61. In the year 1996, what is the difference between the Gross enrolment ratio (%) of High income: nonOECD and Gross enrolment ratio (%) of United States?
Provide a succinct answer. -39.3. In the year 1996, what is the difference between the Gross enrolment ratio (%) in Kuwait and Gross enrolment ratio (%) in Portugal?
Give a very brief answer. -14.4. In the year 1996, what is the difference between the Gross enrolment ratio (%) of Kuwait and Gross enrolment ratio (%) of United States?
Offer a terse response. -53.09. In the year 1996, what is the difference between the Gross enrolment ratio (%) of Portugal and Gross enrolment ratio (%) of United States?
Offer a very short reply. -38.69. In the year 1999, what is the difference between the Gross enrolment ratio (%) of High income: nonOECD and Gross enrolment ratio (%) of Kuwait?
Offer a terse response. 20.04. In the year 1999, what is the difference between the Gross enrolment ratio (%) of High income: nonOECD and Gross enrolment ratio (%) of Portugal?
Your answer should be compact. -1.82. In the year 1999, what is the difference between the Gross enrolment ratio (%) of High income: nonOECD and Gross enrolment ratio (%) of United States?
Your answer should be very brief. -29.1. In the year 1999, what is the difference between the Gross enrolment ratio (%) in Kuwait and Gross enrolment ratio (%) in Portugal?
Offer a terse response. -21.86. In the year 1999, what is the difference between the Gross enrolment ratio (%) in Kuwait and Gross enrolment ratio (%) in United States?
Provide a short and direct response. -49.14. In the year 1999, what is the difference between the Gross enrolment ratio (%) of Portugal and Gross enrolment ratio (%) of United States?
Provide a short and direct response. -27.28. In the year 2001, what is the difference between the Gross enrolment ratio (%) in High income: nonOECD and Gross enrolment ratio (%) in Kuwait?
Provide a succinct answer. 26.93. In the year 2001, what is the difference between the Gross enrolment ratio (%) of High income: nonOECD and Gross enrolment ratio (%) of Portugal?
Provide a short and direct response. 0.24. In the year 2001, what is the difference between the Gross enrolment ratio (%) in High income: nonOECD and Gross enrolment ratio (%) in United States?
Your answer should be very brief. -18. In the year 2001, what is the difference between the Gross enrolment ratio (%) in Kuwait and Gross enrolment ratio (%) in Portugal?
Your answer should be compact. -26.69. In the year 2001, what is the difference between the Gross enrolment ratio (%) of Kuwait and Gross enrolment ratio (%) of United States?
Your response must be concise. -44.93. In the year 2001, what is the difference between the Gross enrolment ratio (%) of Portugal and Gross enrolment ratio (%) of United States?
Offer a very short reply. -18.24. In the year 2002, what is the difference between the Gross enrolment ratio (%) of High income: nonOECD and Gross enrolment ratio (%) of Kuwait?
Make the answer very short. 30.7. In the year 2002, what is the difference between the Gross enrolment ratio (%) of High income: nonOECD and Gross enrolment ratio (%) of Portugal?
Keep it short and to the point. 1.76. In the year 2002, what is the difference between the Gross enrolment ratio (%) of High income: nonOECD and Gross enrolment ratio (%) of United States?
Ensure brevity in your answer.  -24.28. In the year 2002, what is the difference between the Gross enrolment ratio (%) in Kuwait and Gross enrolment ratio (%) in Portugal?
Provide a succinct answer. -28.94. In the year 2002, what is the difference between the Gross enrolment ratio (%) in Kuwait and Gross enrolment ratio (%) in United States?
Ensure brevity in your answer.  -54.98. In the year 2002, what is the difference between the Gross enrolment ratio (%) in Portugal and Gross enrolment ratio (%) in United States?
Keep it short and to the point. -26.04. In the year 2003, what is the difference between the Gross enrolment ratio (%) in High income: nonOECD and Gross enrolment ratio (%) in Kuwait?
Provide a short and direct response. 34.41. In the year 2003, what is the difference between the Gross enrolment ratio (%) in High income: nonOECD and Gross enrolment ratio (%) in Portugal?
Your response must be concise. 2.68. In the year 2003, what is the difference between the Gross enrolment ratio (%) of High income: nonOECD and Gross enrolment ratio (%) of United States?
Your response must be concise. -23.17. In the year 2003, what is the difference between the Gross enrolment ratio (%) of Kuwait and Gross enrolment ratio (%) of Portugal?
Ensure brevity in your answer.  -31.73. In the year 2003, what is the difference between the Gross enrolment ratio (%) in Kuwait and Gross enrolment ratio (%) in United States?
Provide a short and direct response. -57.57. In the year 2003, what is the difference between the Gross enrolment ratio (%) in Portugal and Gross enrolment ratio (%) in United States?
Your answer should be very brief. -25.85. In the year 2004, what is the difference between the Gross enrolment ratio (%) of High income: nonOECD and Gross enrolment ratio (%) of Kuwait?
Provide a succinct answer. 35.52. In the year 2004, what is the difference between the Gross enrolment ratio (%) in High income: nonOECD and Gross enrolment ratio (%) in Portugal?
Keep it short and to the point. 2.11. In the year 2004, what is the difference between the Gross enrolment ratio (%) in High income: nonOECD and Gross enrolment ratio (%) in United States?
Your answer should be very brief. -22.92. In the year 2004, what is the difference between the Gross enrolment ratio (%) of Kuwait and Gross enrolment ratio (%) of Portugal?
Keep it short and to the point. -33.41. In the year 2004, what is the difference between the Gross enrolment ratio (%) in Kuwait and Gross enrolment ratio (%) in United States?
Your answer should be compact. -58.44. In the year 2004, what is the difference between the Gross enrolment ratio (%) of Portugal and Gross enrolment ratio (%) of United States?
Ensure brevity in your answer.  -25.03. In the year 2013, what is the difference between the Gross enrolment ratio (%) in High income: nonOECD and Gross enrolment ratio (%) in Kuwait?
Offer a terse response. 38.81. In the year 2013, what is the difference between the Gross enrolment ratio (%) of High income: nonOECD and Gross enrolment ratio (%) of Portugal?
Give a very brief answer. 1.31. In the year 2013, what is the difference between the Gross enrolment ratio (%) of High income: nonOECD and Gross enrolment ratio (%) of United States?
Provide a short and direct response. -21.82. In the year 2013, what is the difference between the Gross enrolment ratio (%) of Kuwait and Gross enrolment ratio (%) of Portugal?
Your answer should be compact. -37.5. In the year 2013, what is the difference between the Gross enrolment ratio (%) of Kuwait and Gross enrolment ratio (%) of United States?
Give a very brief answer. -60.63. In the year 2013, what is the difference between the Gross enrolment ratio (%) of Portugal and Gross enrolment ratio (%) of United States?
Provide a short and direct response. -23.14. What is the ratio of the Gross enrolment ratio (%) of High income: nonOECD in 1995 to that in 1996?
Provide a short and direct response. 0.96. What is the ratio of the Gross enrolment ratio (%) in Kuwait in 1995 to that in 1996?
Keep it short and to the point. 0.83. What is the ratio of the Gross enrolment ratio (%) in Portugal in 1995 to that in 1996?
Make the answer very short. 0.94. What is the ratio of the Gross enrolment ratio (%) of United States in 1995 to that in 1996?
Provide a short and direct response. 1.01. What is the ratio of the Gross enrolment ratio (%) in High income: nonOECD in 1995 to that in 1999?
Keep it short and to the point. 0.86. What is the ratio of the Gross enrolment ratio (%) in Kuwait in 1995 to that in 1999?
Your answer should be very brief. 0.89. What is the ratio of the Gross enrolment ratio (%) of Portugal in 1995 to that in 1999?
Provide a short and direct response. 0.82. What is the ratio of the Gross enrolment ratio (%) in United States in 1995 to that in 1999?
Provide a short and direct response. 1.08. What is the ratio of the Gross enrolment ratio (%) in High income: nonOECD in 1995 to that in 2001?
Provide a succinct answer. 0.73. What is the ratio of the Gross enrolment ratio (%) of Kuwait in 1995 to that in 2001?
Offer a terse response. 0.85. What is the ratio of the Gross enrolment ratio (%) of Portugal in 1995 to that in 2001?
Give a very brief answer. 0.72. What is the ratio of the Gross enrolment ratio (%) in United States in 1995 to that in 2001?
Your answer should be very brief. 1.14. What is the ratio of the Gross enrolment ratio (%) in High income: nonOECD in 1995 to that in 2002?
Give a very brief answer. 0.67. What is the ratio of the Gross enrolment ratio (%) in Kuwait in 1995 to that in 2002?
Make the answer very short. 0.85. What is the ratio of the Gross enrolment ratio (%) in Portugal in 1995 to that in 2002?
Your response must be concise. 0.69. What is the ratio of the Gross enrolment ratio (%) of United States in 1995 to that in 2002?
Your response must be concise. 0.99. What is the ratio of the Gross enrolment ratio (%) of High income: nonOECD in 1995 to that in 2003?
Provide a succinct answer. 0.64. What is the ratio of the Gross enrolment ratio (%) in Kuwait in 1995 to that in 2003?
Make the answer very short. 0.88. What is the ratio of the Gross enrolment ratio (%) of Portugal in 1995 to that in 2003?
Provide a succinct answer. 0.66. What is the ratio of the Gross enrolment ratio (%) of United States in 1995 to that in 2003?
Ensure brevity in your answer.  0.97. What is the ratio of the Gross enrolment ratio (%) in High income: nonOECD in 1995 to that in 2004?
Provide a succinct answer. 0.63. What is the ratio of the Gross enrolment ratio (%) in Kuwait in 1995 to that in 2004?
Offer a very short reply. 0.91. What is the ratio of the Gross enrolment ratio (%) in Portugal in 1995 to that in 2004?
Give a very brief answer. 0.65. What is the ratio of the Gross enrolment ratio (%) in United States in 1995 to that in 2004?
Provide a short and direct response. 0.97. What is the ratio of the Gross enrolment ratio (%) in High income: nonOECD in 1995 to that in 2013?
Your answer should be compact. 0.55. What is the ratio of the Gross enrolment ratio (%) in Kuwait in 1995 to that in 2013?
Ensure brevity in your answer.  0.71. What is the ratio of the Gross enrolment ratio (%) in Portugal in 1995 to that in 2013?
Your response must be concise. 0.55. What is the ratio of the Gross enrolment ratio (%) in United States in 1995 to that in 2013?
Ensure brevity in your answer.  0.88. What is the ratio of the Gross enrolment ratio (%) of High income: nonOECD in 1996 to that in 1999?
Make the answer very short. 0.89. What is the ratio of the Gross enrolment ratio (%) of Kuwait in 1996 to that in 1999?
Ensure brevity in your answer.  1.07. What is the ratio of the Gross enrolment ratio (%) of Portugal in 1996 to that in 1999?
Make the answer very short. 0.87. What is the ratio of the Gross enrolment ratio (%) of United States in 1996 to that in 1999?
Your response must be concise. 1.08. What is the ratio of the Gross enrolment ratio (%) in High income: nonOECD in 1996 to that in 2001?
Offer a very short reply. 0.75. What is the ratio of the Gross enrolment ratio (%) in Kuwait in 1996 to that in 2001?
Offer a very short reply. 1.03. What is the ratio of the Gross enrolment ratio (%) in Portugal in 1996 to that in 2001?
Make the answer very short. 0.77. What is the ratio of the Gross enrolment ratio (%) in United States in 1996 to that in 2001?
Offer a very short reply. 1.13. What is the ratio of the Gross enrolment ratio (%) in High income: nonOECD in 1996 to that in 2002?
Offer a very short reply. 0.7. What is the ratio of the Gross enrolment ratio (%) in Kuwait in 1996 to that in 2002?
Provide a succinct answer. 1.02. What is the ratio of the Gross enrolment ratio (%) of Portugal in 1996 to that in 2002?
Ensure brevity in your answer.  0.73. What is the ratio of the Gross enrolment ratio (%) of United States in 1996 to that in 2002?
Make the answer very short. 0.98. What is the ratio of the Gross enrolment ratio (%) of High income: nonOECD in 1996 to that in 2003?
Your answer should be compact. 0.66. What is the ratio of the Gross enrolment ratio (%) in Kuwait in 1996 to that in 2003?
Ensure brevity in your answer.  1.06. What is the ratio of the Gross enrolment ratio (%) of Portugal in 1996 to that in 2003?
Your response must be concise. 0.71. What is the ratio of the Gross enrolment ratio (%) of United States in 1996 to that in 2003?
Provide a succinct answer. 0.96. What is the ratio of the Gross enrolment ratio (%) in High income: nonOECD in 1996 to that in 2004?
Offer a terse response. 0.66. What is the ratio of the Gross enrolment ratio (%) of Kuwait in 1996 to that in 2004?
Give a very brief answer. 1.09. What is the ratio of the Gross enrolment ratio (%) in Portugal in 1996 to that in 2004?
Offer a very short reply. 0.7. What is the ratio of the Gross enrolment ratio (%) of United States in 1996 to that in 2004?
Keep it short and to the point. 0.96. What is the ratio of the Gross enrolment ratio (%) of High income: nonOECD in 1996 to that in 2013?
Give a very brief answer. 0.57. What is the ratio of the Gross enrolment ratio (%) of Kuwait in 1996 to that in 2013?
Keep it short and to the point. 0.86. What is the ratio of the Gross enrolment ratio (%) of Portugal in 1996 to that in 2013?
Ensure brevity in your answer.  0.59. What is the ratio of the Gross enrolment ratio (%) in United States in 1996 to that in 2013?
Your response must be concise. 0.87. What is the ratio of the Gross enrolment ratio (%) in High income: nonOECD in 1999 to that in 2001?
Your answer should be very brief. 0.85. What is the ratio of the Gross enrolment ratio (%) of Kuwait in 1999 to that in 2001?
Your answer should be very brief. 0.96. What is the ratio of the Gross enrolment ratio (%) of Portugal in 1999 to that in 2001?
Provide a succinct answer. 0.89. What is the ratio of the Gross enrolment ratio (%) of United States in 1999 to that in 2001?
Make the answer very short. 1.05. What is the ratio of the Gross enrolment ratio (%) of High income: nonOECD in 1999 to that in 2002?
Make the answer very short. 0.79. What is the ratio of the Gross enrolment ratio (%) of Kuwait in 1999 to that in 2002?
Offer a terse response. 0.96. What is the ratio of the Gross enrolment ratio (%) of Portugal in 1999 to that in 2002?
Make the answer very short. 0.85. What is the ratio of the Gross enrolment ratio (%) of United States in 1999 to that in 2002?
Make the answer very short. 0.91. What is the ratio of the Gross enrolment ratio (%) of High income: nonOECD in 1999 to that in 2003?
Make the answer very short. 0.74. What is the ratio of the Gross enrolment ratio (%) of Kuwait in 1999 to that in 2003?
Give a very brief answer. 0.99. What is the ratio of the Gross enrolment ratio (%) in Portugal in 1999 to that in 2003?
Give a very brief answer. 0.81. What is the ratio of the Gross enrolment ratio (%) of United States in 1999 to that in 2003?
Your answer should be very brief. 0.89. What is the ratio of the Gross enrolment ratio (%) of High income: nonOECD in 1999 to that in 2004?
Your answer should be very brief. 0.74. What is the ratio of the Gross enrolment ratio (%) of Kuwait in 1999 to that in 2004?
Offer a terse response. 1.02. What is the ratio of the Gross enrolment ratio (%) of Portugal in 1999 to that in 2004?
Offer a terse response. 0.8. What is the ratio of the Gross enrolment ratio (%) in United States in 1999 to that in 2004?
Make the answer very short. 0.89. What is the ratio of the Gross enrolment ratio (%) of High income: nonOECD in 1999 to that in 2013?
Offer a terse response. 0.64. What is the ratio of the Gross enrolment ratio (%) of Kuwait in 1999 to that in 2013?
Your answer should be very brief. 0.8. What is the ratio of the Gross enrolment ratio (%) of Portugal in 1999 to that in 2013?
Offer a very short reply. 0.68. What is the ratio of the Gross enrolment ratio (%) in United States in 1999 to that in 2013?
Give a very brief answer. 0.81. What is the ratio of the Gross enrolment ratio (%) of High income: nonOECD in 2001 to that in 2002?
Offer a very short reply. 0.93. What is the ratio of the Gross enrolment ratio (%) of Kuwait in 2001 to that in 2002?
Make the answer very short. 0.99. What is the ratio of the Gross enrolment ratio (%) in Portugal in 2001 to that in 2002?
Provide a short and direct response. 0.95. What is the ratio of the Gross enrolment ratio (%) of United States in 2001 to that in 2002?
Give a very brief answer. 0.87. What is the ratio of the Gross enrolment ratio (%) of High income: nonOECD in 2001 to that in 2003?
Provide a succinct answer. 0.88. What is the ratio of the Gross enrolment ratio (%) in Kuwait in 2001 to that in 2003?
Give a very brief answer. 1.03. What is the ratio of the Gross enrolment ratio (%) of Portugal in 2001 to that in 2003?
Keep it short and to the point. 0.92. What is the ratio of the Gross enrolment ratio (%) of United States in 2001 to that in 2003?
Your answer should be very brief. 0.85. What is the ratio of the Gross enrolment ratio (%) in High income: nonOECD in 2001 to that in 2004?
Your answer should be very brief. 0.88. What is the ratio of the Gross enrolment ratio (%) in Kuwait in 2001 to that in 2004?
Your response must be concise. 1.06. What is the ratio of the Gross enrolment ratio (%) in Portugal in 2001 to that in 2004?
Keep it short and to the point. 0.9. What is the ratio of the Gross enrolment ratio (%) of United States in 2001 to that in 2004?
Provide a short and direct response. 0.85. What is the ratio of the Gross enrolment ratio (%) in High income: nonOECD in 2001 to that in 2013?
Your response must be concise. 0.75. What is the ratio of the Gross enrolment ratio (%) in Kuwait in 2001 to that in 2013?
Provide a short and direct response. 0.83. What is the ratio of the Gross enrolment ratio (%) of Portugal in 2001 to that in 2013?
Your response must be concise. 0.76. What is the ratio of the Gross enrolment ratio (%) in United States in 2001 to that in 2013?
Provide a succinct answer. 0.77. What is the ratio of the Gross enrolment ratio (%) of High income: nonOECD in 2002 to that in 2003?
Make the answer very short. 0.95. What is the ratio of the Gross enrolment ratio (%) in Kuwait in 2002 to that in 2003?
Provide a succinct answer. 1.03. What is the ratio of the Gross enrolment ratio (%) of Portugal in 2002 to that in 2003?
Keep it short and to the point. 0.96. What is the ratio of the Gross enrolment ratio (%) of United States in 2002 to that in 2003?
Offer a terse response. 0.98. What is the ratio of the Gross enrolment ratio (%) in High income: nonOECD in 2002 to that in 2004?
Your answer should be very brief. 0.94. What is the ratio of the Gross enrolment ratio (%) in Kuwait in 2002 to that in 2004?
Your response must be concise. 1.07. What is the ratio of the Gross enrolment ratio (%) of Portugal in 2002 to that in 2004?
Your answer should be very brief. 0.95. What is the ratio of the Gross enrolment ratio (%) of United States in 2002 to that in 2004?
Offer a terse response. 0.98. What is the ratio of the Gross enrolment ratio (%) of High income: nonOECD in 2002 to that in 2013?
Offer a very short reply. 0.81. What is the ratio of the Gross enrolment ratio (%) in Kuwait in 2002 to that in 2013?
Keep it short and to the point. 0.84. What is the ratio of the Gross enrolment ratio (%) in Portugal in 2002 to that in 2013?
Your answer should be compact. 0.8. What is the ratio of the Gross enrolment ratio (%) of United States in 2002 to that in 2013?
Provide a short and direct response. 0.88. What is the ratio of the Gross enrolment ratio (%) in Kuwait in 2003 to that in 2004?
Make the answer very short. 1.04. What is the ratio of the Gross enrolment ratio (%) in Portugal in 2003 to that in 2004?
Offer a very short reply. 0.98. What is the ratio of the Gross enrolment ratio (%) in United States in 2003 to that in 2004?
Ensure brevity in your answer.  1. What is the ratio of the Gross enrolment ratio (%) of High income: nonOECD in 2003 to that in 2013?
Ensure brevity in your answer.  0.85. What is the ratio of the Gross enrolment ratio (%) in Kuwait in 2003 to that in 2013?
Keep it short and to the point. 0.81. What is the ratio of the Gross enrolment ratio (%) of Portugal in 2003 to that in 2013?
Your answer should be compact. 0.83. What is the ratio of the Gross enrolment ratio (%) in United States in 2003 to that in 2013?
Offer a terse response. 0.91. What is the ratio of the Gross enrolment ratio (%) in High income: nonOECD in 2004 to that in 2013?
Your answer should be compact. 0.86. What is the ratio of the Gross enrolment ratio (%) in Kuwait in 2004 to that in 2013?
Your answer should be compact. 0.78. What is the ratio of the Gross enrolment ratio (%) of Portugal in 2004 to that in 2013?
Your response must be concise. 0.84. What is the ratio of the Gross enrolment ratio (%) in United States in 2004 to that in 2013?
Give a very brief answer. 0.91. What is the difference between the highest and the second highest Gross enrolment ratio (%) in High income: nonOECD?
Provide a succinct answer. 9.44. What is the difference between the highest and the second highest Gross enrolment ratio (%) in Kuwait?
Offer a terse response. 4.09. What is the difference between the highest and the second highest Gross enrolment ratio (%) in Portugal?
Ensure brevity in your answer.  10.23. What is the difference between the highest and the second highest Gross enrolment ratio (%) in United States?
Provide a short and direct response. 8.34. What is the difference between the highest and the lowest Gross enrolment ratio (%) in High income: nonOECD?
Offer a terse response. 30.55. What is the difference between the highest and the lowest Gross enrolment ratio (%) of Kuwait?
Provide a short and direct response. 8.23. What is the difference between the highest and the lowest Gross enrolment ratio (%) in Portugal?
Make the answer very short. 29.52. What is the difference between the highest and the lowest Gross enrolment ratio (%) of United States?
Make the answer very short. 20.46. 